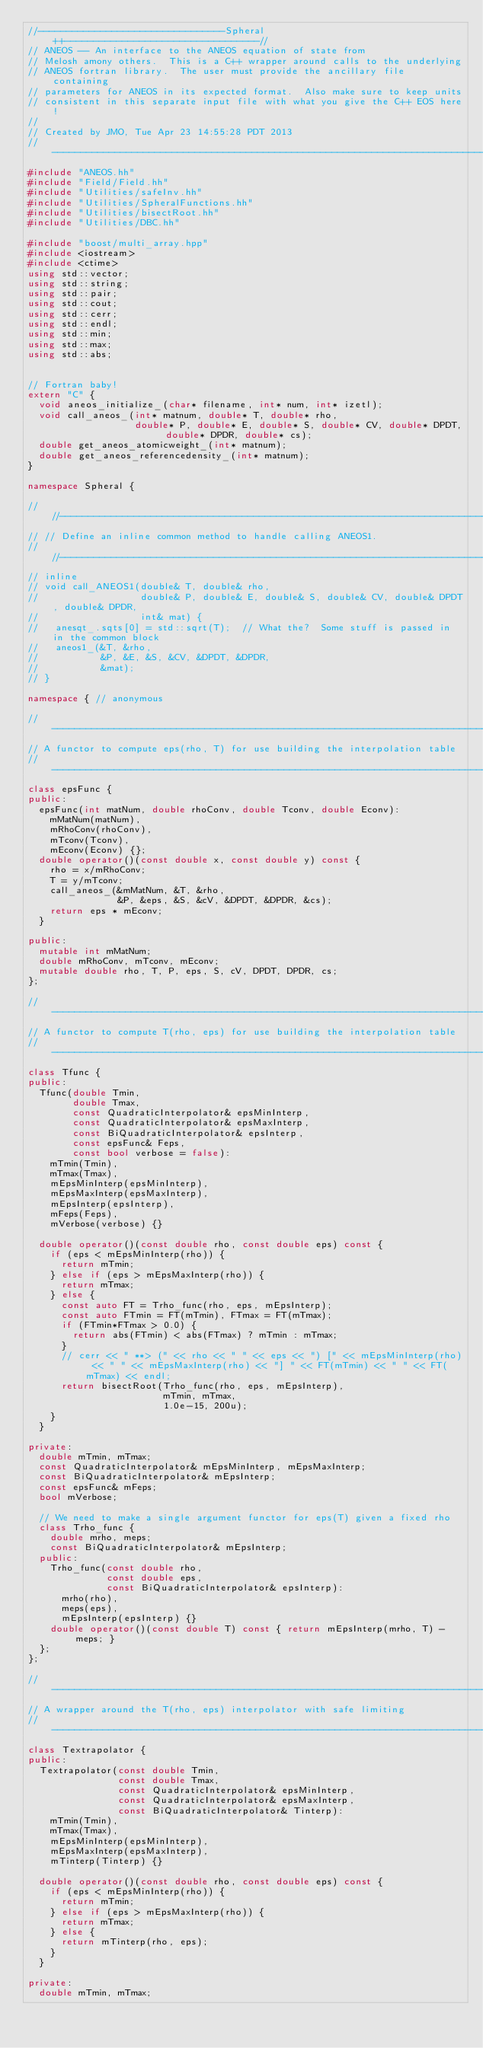Convert code to text. <code><loc_0><loc_0><loc_500><loc_500><_C++_>//---------------------------------Spheral++----------------------------------//
// ANEOS -- An interface to the ANEOS equation of state from 
// Melosh amony others.  This is a C++ wrapper around calls to the underlying
// ANEOS fortran library.  The user must provide the ancillary file containing
// parameters for ANEOS in its expected format.  Also make sure to keep units
// consistent in this separate input file with what you give the C++ EOS here!
//
// Created by JMO, Tue Apr 23 14:55:28 PDT 2013
//----------------------------------------------------------------------------//
#include "ANEOS.hh"
#include "Field/Field.hh"
#include "Utilities/safeInv.hh"
#include "Utilities/SpheralFunctions.hh"
#include "Utilities/bisectRoot.hh"
#include "Utilities/DBC.hh"

#include "boost/multi_array.hpp"
#include <iostream>
#include <ctime>
using std::vector;
using std::string;
using std::pair;
using std::cout;
using std::cerr;
using std::endl;
using std::min;
using std::max;
using std::abs;


// Fortran baby!
extern "C" {
  void aneos_initialize_(char* filename, int* num, int* izetl);
  void call_aneos_(int* matnum, double* T, double* rho, 
                   double* P, double* E, double* S, double* CV, double* DPDT, double* DPDR, double* cs);
  double get_aneos_atomicweight_(int* matnum);
  double get_aneos_referencedensity_(int* matnum);
}

namespace Spheral {

// //------------------------------------------------------------------------------
// // Define an inline common method to handle calling ANEOS1.
// //------------------------------------------------------------------------------
// inline
// void call_ANEOS1(double& T, double& rho, 
//                  double& P, double& E, double& S, double& CV, double& DPDT, double& DPDR,
//                  int& mat) {
//   anesqt_.sqts[0] = std::sqrt(T);  // What the?  Some stuff is passed in in the common block
//   aneos1_(&T, &rho, 
//           &P, &E, &S, &CV, &DPDT, &DPDR,
//           &mat);
// }

namespace { // anonymous

//------------------------------------------------------------------------------
// A functor to compute eps(rho, T) for use building the interpolation table
//------------------------------------------------------------------------------
class epsFunc {
public:
  epsFunc(int matNum, double rhoConv, double Tconv, double Econv):
    mMatNum(matNum),
    mRhoConv(rhoConv),
    mTconv(Tconv),
    mEconv(Econv) {};
  double operator()(const double x, const double y) const {
    rho = x/mRhoConv;
    T = y/mTconv;
    call_aneos_(&mMatNum, &T, &rho,
                &P, &eps, &S, &cV, &DPDT, &DPDR, &cs);
    return eps * mEconv;
  }

public:
  mutable int mMatNum;
  double mRhoConv, mTconv, mEconv;
  mutable double rho, T, P, eps, S, cV, DPDT, DPDR, cs;
};

//------------------------------------------------------------------------------
// A functor to compute T(rho, eps) for use building the interpolation table
//------------------------------------------------------------------------------
class Tfunc {
public:
  Tfunc(double Tmin, 
        double Tmax,
        const QuadraticInterpolator& epsMinInterp,
        const QuadraticInterpolator& epsMaxInterp,
        const BiQuadraticInterpolator& epsInterp,
        const epsFunc& Feps,
        const bool verbose = false):
    mTmin(Tmin),
    mTmax(Tmax),
    mEpsMinInterp(epsMinInterp),
    mEpsMaxInterp(epsMaxInterp),
    mEpsInterp(epsInterp),
    mFeps(Feps),
    mVerbose(verbose) {}

  double operator()(const double rho, const double eps) const {
    if (eps < mEpsMinInterp(rho)) {
      return mTmin;
    } else if (eps > mEpsMaxInterp(rho)) {
      return mTmax;
    } else {
      const auto FT = Trho_func(rho, eps, mEpsInterp);
      const auto FTmin = FT(mTmin), FTmax = FT(mTmax);
      if (FTmin*FTmax > 0.0) {
        return abs(FTmin) < abs(FTmax) ? mTmin : mTmax;
      }
      // cerr << " **> (" << rho << " " << eps << ") [" << mEpsMinInterp(rho) << " " << mEpsMaxInterp(rho) << "] " << FT(mTmin) << " " << FT(mTmax) << endl;
      return bisectRoot(Trho_func(rho, eps, mEpsInterp),
                        mTmin, mTmax,
                        1.0e-15, 200u);
    }
  }

private:
  double mTmin, mTmax;
  const QuadraticInterpolator& mEpsMinInterp, mEpsMaxInterp;
  const BiQuadraticInterpolator& mEpsInterp;
  const epsFunc& mFeps;
  bool mVerbose;

  // We need to make a single argument functor for eps(T) given a fixed rho
  class Trho_func {
    double mrho, meps;
    const BiQuadraticInterpolator& mEpsInterp;
  public:
    Trho_func(const double rho,
              const double eps,
              const BiQuadraticInterpolator& epsInterp):
      mrho(rho),
      meps(eps),
      mEpsInterp(epsInterp) {}
    double operator()(const double T) const { return mEpsInterp(mrho, T) - meps; }
  };
};

//------------------------------------------------------------------------------
// A wrapper around the T(rho, eps) interpolator with safe limiting
//------------------------------------------------------------------------------
class Textrapolator {
public:
  Textrapolator(const double Tmin,
                const double Tmax,
                const QuadraticInterpolator& epsMinInterp,
                const QuadraticInterpolator& epsMaxInterp,
                const BiQuadraticInterpolator& Tinterp):
    mTmin(Tmin),
    mTmax(Tmax),
    mEpsMinInterp(epsMinInterp),
    mEpsMaxInterp(epsMaxInterp),
    mTinterp(Tinterp) {}

  double operator()(const double rho, const double eps) const {
    if (eps < mEpsMinInterp(rho)) {
      return mTmin;
    } else if (eps > mEpsMaxInterp(rho)) {
      return mTmax;
    } else {
      return mTinterp(rho, eps);
    }
  }

private:
  double mTmin, mTmax;</code> 